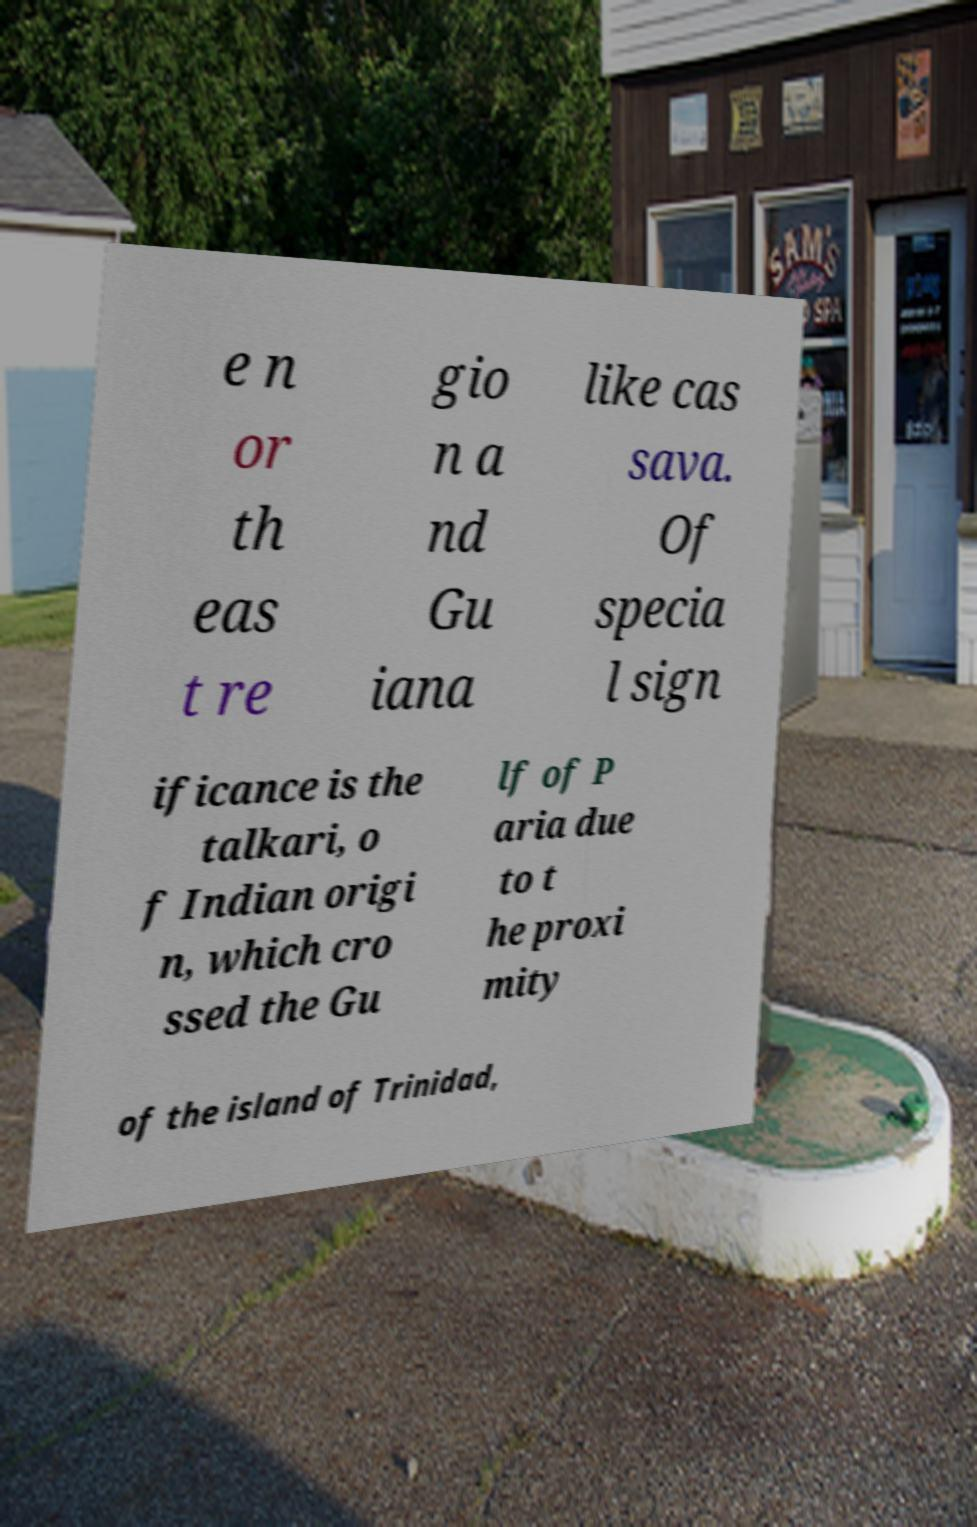Please read and relay the text visible in this image. What does it say? e n or th eas t re gio n a nd Gu iana like cas sava. Of specia l sign ificance is the talkari, o f Indian origi n, which cro ssed the Gu lf of P aria due to t he proxi mity of the island of Trinidad, 